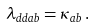Convert formula to latex. <formula><loc_0><loc_0><loc_500><loc_500>\lambda _ { d d a b } = \kappa _ { a b } \, .</formula> 